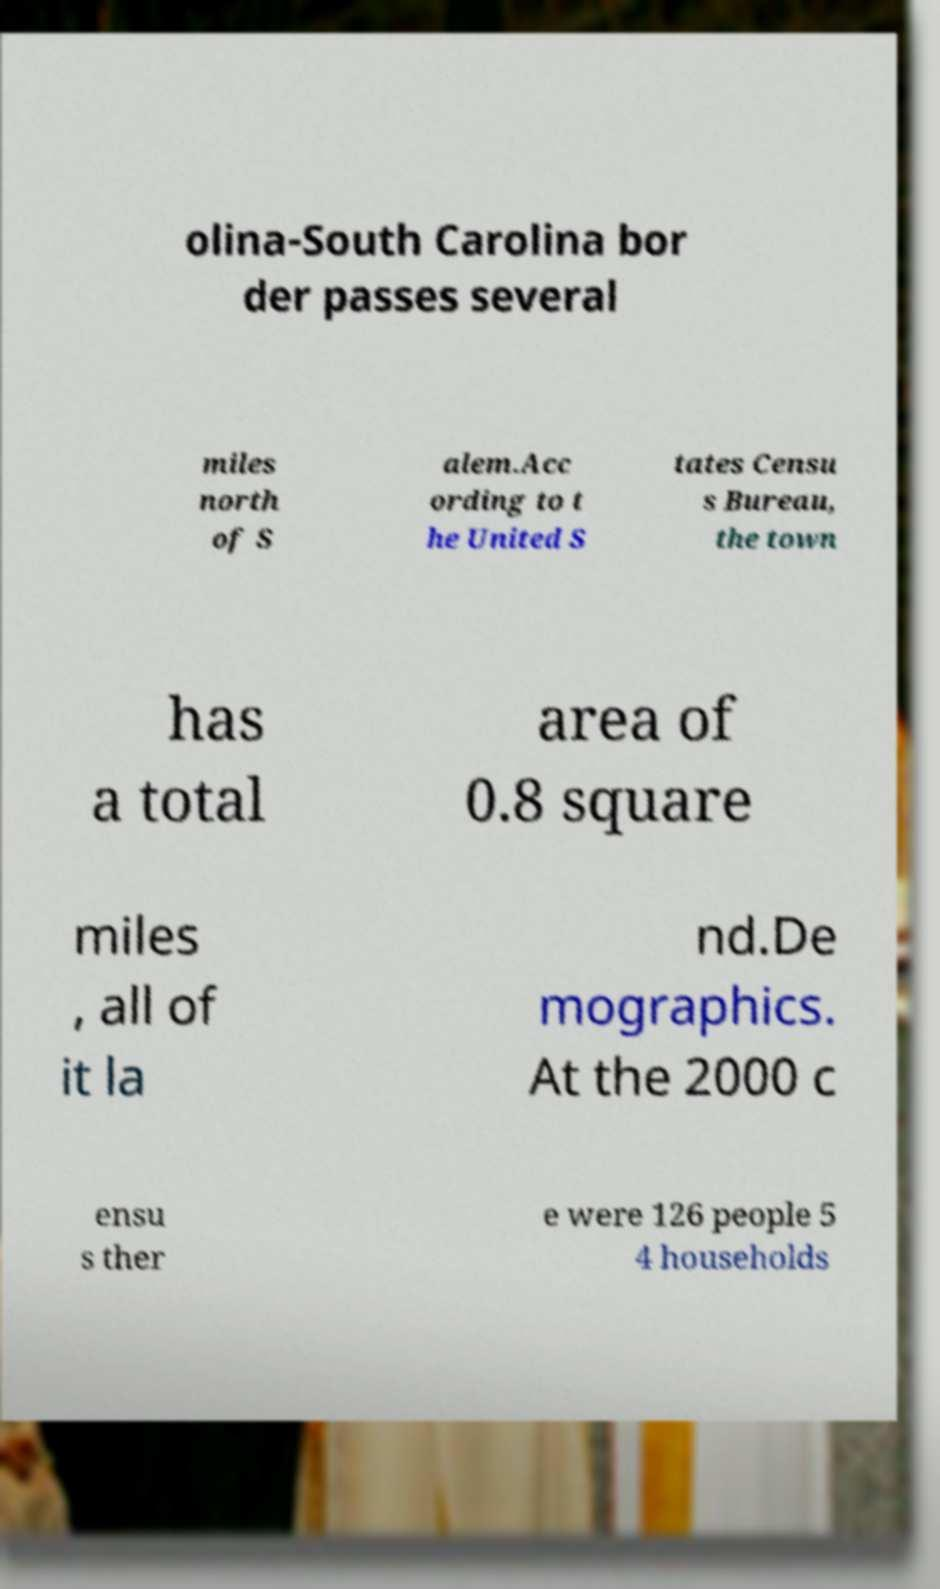What messages or text are displayed in this image? I need them in a readable, typed format. olina-South Carolina bor der passes several miles north of S alem.Acc ording to t he United S tates Censu s Bureau, the town has a total area of 0.8 square miles , all of it la nd.De mographics. At the 2000 c ensu s ther e were 126 people 5 4 households 